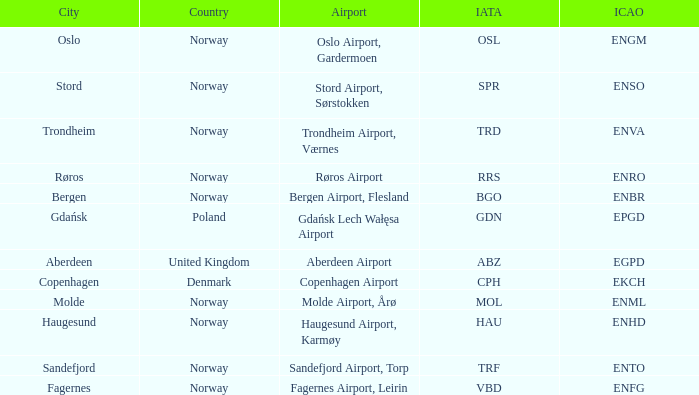What is th IATA for Norway with an ICAO of ENTO? TRF. Parse the full table. {'header': ['City', 'Country', 'Airport', 'IATA', 'ICAO'], 'rows': [['Oslo', 'Norway', 'Oslo Airport, Gardermoen', 'OSL', 'ENGM'], ['Stord', 'Norway', 'Stord Airport, Sørstokken', 'SPR', 'ENSO'], ['Trondheim', 'Norway', 'Trondheim Airport, Værnes', 'TRD', 'ENVA'], ['Røros', 'Norway', 'Røros Airport', 'RRS', 'ENRO'], ['Bergen', 'Norway', 'Bergen Airport, Flesland', 'BGO', 'ENBR'], ['Gdańsk', 'Poland', 'Gdańsk Lech Wałęsa Airport', 'GDN', 'EPGD'], ['Aberdeen', 'United Kingdom', 'Aberdeen Airport', 'ABZ', 'EGPD'], ['Copenhagen', 'Denmark', 'Copenhagen Airport', 'CPH', 'EKCH'], ['Molde', 'Norway', 'Molde Airport, Årø', 'MOL', 'ENML'], ['Haugesund', 'Norway', 'Haugesund Airport, Karmøy', 'HAU', 'ENHD'], ['Sandefjord', 'Norway', 'Sandefjord Airport, Torp', 'TRF', 'ENTO'], ['Fagernes', 'Norway', 'Fagernes Airport, Leirin', 'VBD', 'ENFG']]} 